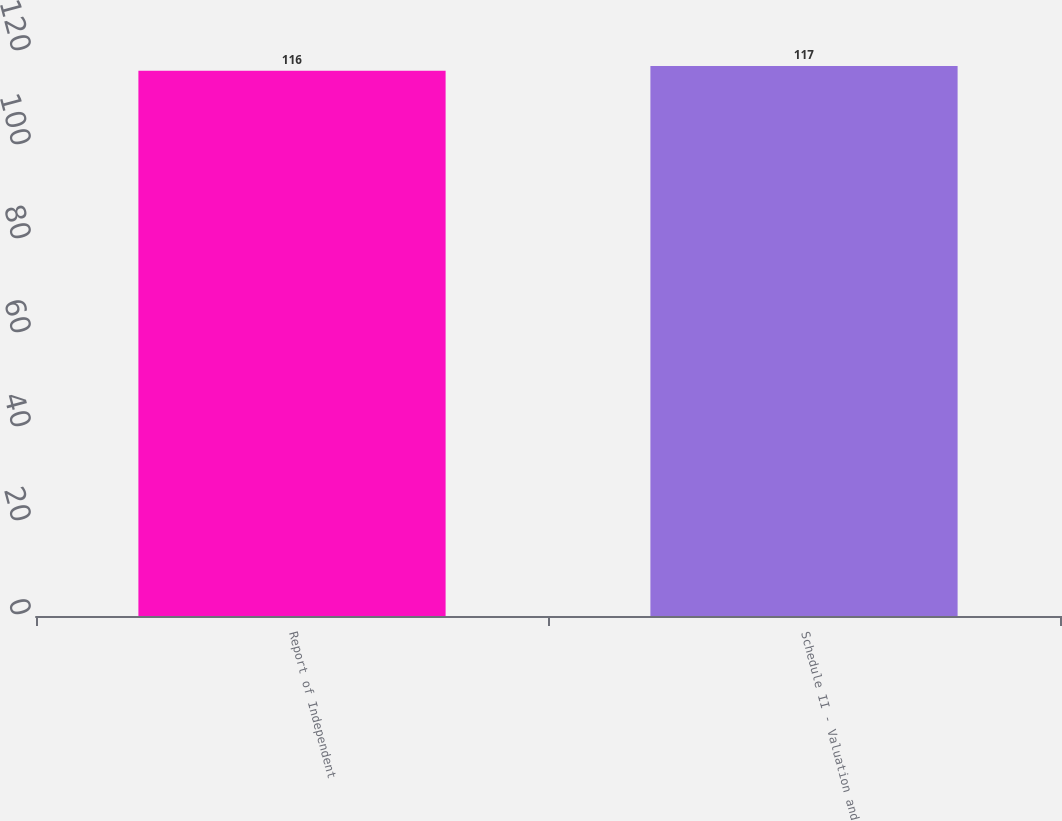Convert chart. <chart><loc_0><loc_0><loc_500><loc_500><bar_chart><fcel>Report of Independent<fcel>Schedule II - Valuation and<nl><fcel>116<fcel>117<nl></chart> 